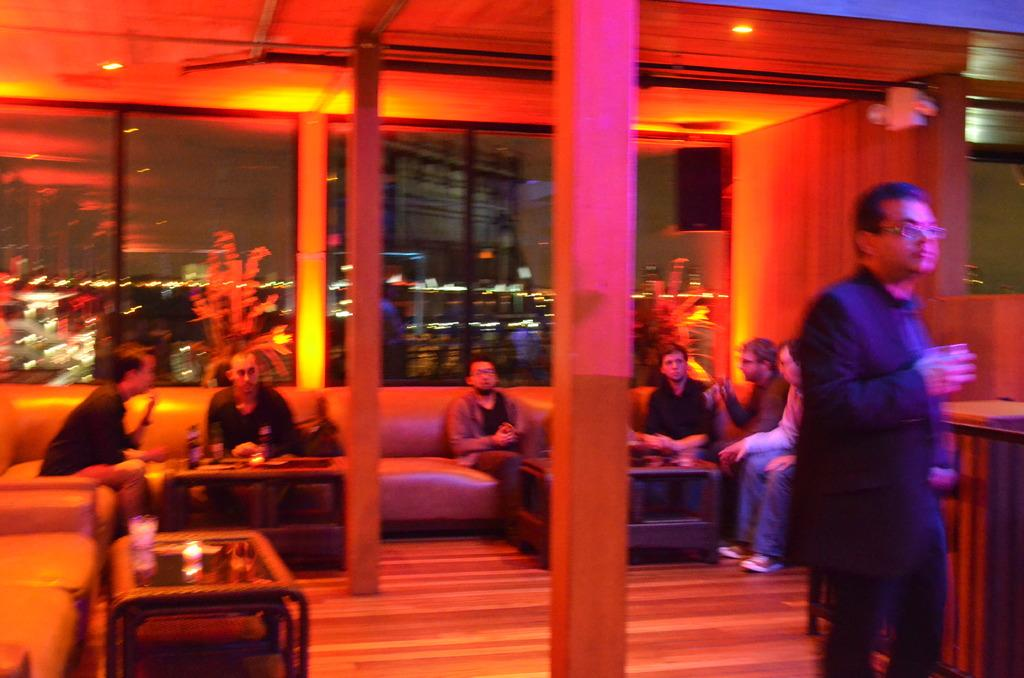What are the people in the image doing? There are people sitting on couches in the image. Can you describe the position of the person in the right corner of the image? There is a person standing in the right corner of the image. What architectural features can be seen in the background of the image? There are pillars in the background of the image. What can be seen through the window in the background of the image? There is a window in the background of the image. What type of mouth can be seen on the rat in the image? There is no rat present in the image, so there is no mouth to describe. 